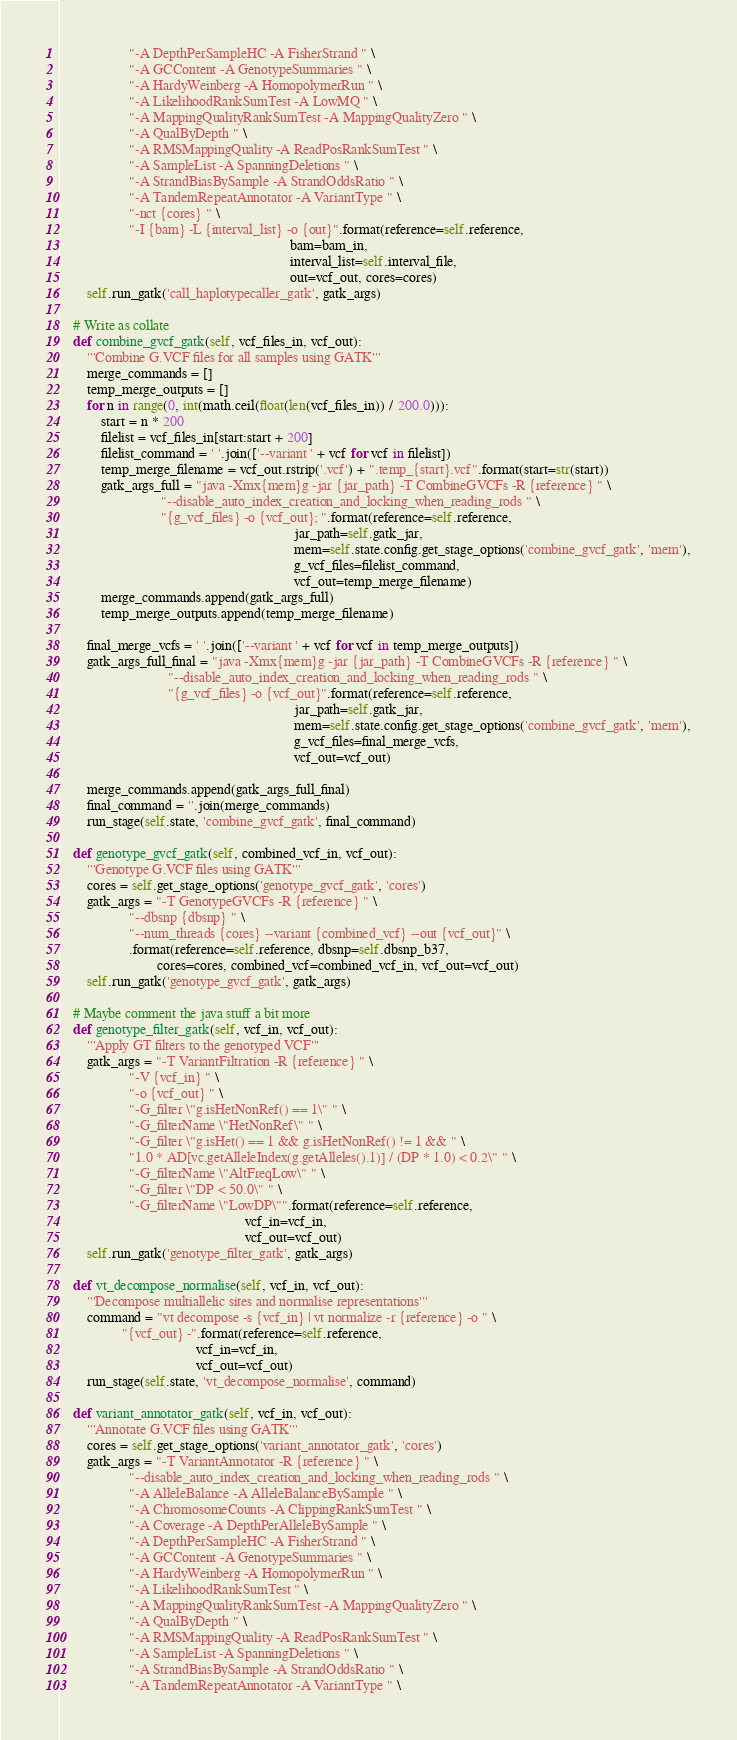<code> <loc_0><loc_0><loc_500><loc_500><_Python_>                    "-A DepthPerSampleHC -A FisherStrand " \
                    "-A GCContent -A GenotypeSummaries " \
                    "-A HardyWeinberg -A HomopolymerRun " \
                    "-A LikelihoodRankSumTest -A LowMQ " \
                    "-A MappingQualityRankSumTest -A MappingQualityZero " \
                    "-A QualByDepth " \
                    "-A RMSMappingQuality -A ReadPosRankSumTest " \
                    "-A SampleList -A SpanningDeletions " \
                    "-A StrandBiasBySample -A StrandOddsRatio " \
                    "-A TandemRepeatAnnotator -A VariantType " \
                    "-nct {cores} " \
                    "-I {bam} -L {interval_list} -o {out}".format(reference=self.reference,
                                                                  bam=bam_in,
                                                                  interval_list=self.interval_file,
                                                                  out=vcf_out, cores=cores)
        self.run_gatk('call_haplotypecaller_gatk', gatk_args)

    # Write as collate
    def combine_gvcf_gatk(self, vcf_files_in, vcf_out):
        '''Combine G.VCF files for all samples using GATK'''
        merge_commands = []
        temp_merge_outputs = []
        for n in range(0, int(math.ceil(float(len(vcf_files_in)) / 200.0))):
            start = n * 200
            filelist = vcf_files_in[start:start + 200]
            filelist_command = ' '.join(['--variant ' + vcf for vcf in filelist])
            temp_merge_filename = vcf_out.rstrip('.vcf') + ".temp_{start}.vcf".format(start=str(start))
            gatk_args_full = "java -Xmx{mem}g -jar {jar_path} -T CombineGVCFs -R {reference} " \
                             "--disable_auto_index_creation_and_locking_when_reading_rods " \
                             "{g_vcf_files} -o {vcf_out}; ".format(reference=self.reference,
                                                                   jar_path=self.gatk_jar,
                                                                   mem=self.state.config.get_stage_options('combine_gvcf_gatk', 'mem'),
                                                                   g_vcf_files=filelist_command,
                                                                   vcf_out=temp_merge_filename)
            merge_commands.append(gatk_args_full)
            temp_merge_outputs.append(temp_merge_filename)

        final_merge_vcfs = ' '.join(['--variant ' + vcf for vcf in temp_merge_outputs])
        gatk_args_full_final = "java -Xmx{mem}g -jar {jar_path} -T CombineGVCFs -R {reference} " \
                               "--disable_auto_index_creation_and_locking_when_reading_rods " \
                               "{g_vcf_files} -o {vcf_out}".format(reference=self.reference,
                                                                   jar_path=self.gatk_jar,
                                                                   mem=self.state.config.get_stage_options('combine_gvcf_gatk', 'mem'),
                                                                   g_vcf_files=final_merge_vcfs,
                                                                   vcf_out=vcf_out)

        merge_commands.append(gatk_args_full_final)
        final_command = ''.join(merge_commands)
        run_stage(self.state, 'combine_gvcf_gatk', final_command)

    def genotype_gvcf_gatk(self, combined_vcf_in, vcf_out):
        '''Genotype G.VCF files using GATK'''
        cores = self.get_stage_options('genotype_gvcf_gatk', 'cores')
        gatk_args = "-T GenotypeGVCFs -R {reference} " \
                    "--dbsnp {dbsnp} " \
                    "--num_threads {cores} --variant {combined_vcf} --out {vcf_out}" \
                    .format(reference=self.reference, dbsnp=self.dbsnp_b37,
                            cores=cores, combined_vcf=combined_vcf_in, vcf_out=vcf_out)
        self.run_gatk('genotype_gvcf_gatk', gatk_args)

    # Maybe comment the java stuff a bit more
    def genotype_filter_gatk(self, vcf_in, vcf_out):
        '''Apply GT filters to the genotyped VCF'''
        gatk_args = "-T VariantFiltration -R {reference} " \
                    "-V {vcf_in} " \
                    "-o {vcf_out} " \
                    "-G_filter \"g.isHetNonRef() == 1\" " \
                    "-G_filterName \"HetNonRef\" " \
                    "-G_filter \"g.isHet() == 1 && g.isHetNonRef() != 1 && " \
                    "1.0 * AD[vc.getAlleleIndex(g.getAlleles().1)] / (DP * 1.0) < 0.2\" " \
                    "-G_filterName \"AltFreqLow\" " \
                    "-G_filter \"DP < 50.0\" " \
                    "-G_filterName \"LowDP\"".format(reference=self.reference,
                                                     vcf_in=vcf_in,
                                                     vcf_out=vcf_out)
        self.run_gatk('genotype_filter_gatk', gatk_args)

    def vt_decompose_normalise(self, vcf_in, vcf_out):
        '''Decompose multiallelic sites and normalise representations'''
        command = "vt decompose -s {vcf_in} | vt normalize -r {reference} -o " \
                  "{vcf_out} -".format(reference=self.reference,
                                       vcf_in=vcf_in,
                                       vcf_out=vcf_out)
        run_stage(self.state, 'vt_decompose_normalise', command)

    def variant_annotator_gatk(self, vcf_in, vcf_out):
        '''Annotate G.VCF files using GATK'''
        cores = self.get_stage_options('variant_annotator_gatk', 'cores')
        gatk_args = "-T VariantAnnotator -R {reference} " \
                    "--disable_auto_index_creation_and_locking_when_reading_rods " \
                    "-A AlleleBalance -A AlleleBalanceBySample " \
                    "-A ChromosomeCounts -A ClippingRankSumTest " \
                    "-A Coverage -A DepthPerAlleleBySample " \
                    "-A DepthPerSampleHC -A FisherStrand " \
                    "-A GCContent -A GenotypeSummaries " \
                    "-A HardyWeinberg -A HomopolymerRun " \
                    "-A LikelihoodRankSumTest " \
                    "-A MappingQualityRankSumTest -A MappingQualityZero " \
                    "-A QualByDepth " \
                    "-A RMSMappingQuality -A ReadPosRankSumTest " \
                    "-A SampleList -A SpanningDeletions " \
                    "-A StrandBiasBySample -A StrandOddsRatio " \
                    "-A TandemRepeatAnnotator -A VariantType " \</code> 